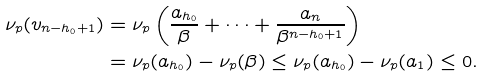Convert formula to latex. <formula><loc_0><loc_0><loc_500><loc_500>\nu _ { p } ( v _ { n - h _ { 0 } + 1 } ) & = \nu _ { p } \left ( \frac { a _ { h _ { 0 } } } { \beta } + \cdots + \frac { a _ { n } } { \beta ^ { n - h _ { 0 } + 1 } } \right ) \\ & = \nu _ { p } ( a _ { h _ { 0 } } ) - \nu _ { p } ( \beta ) \leq \nu _ { p } ( a _ { h _ { 0 } } ) - \nu _ { p } ( a _ { 1 } ) \leq 0 .</formula> 